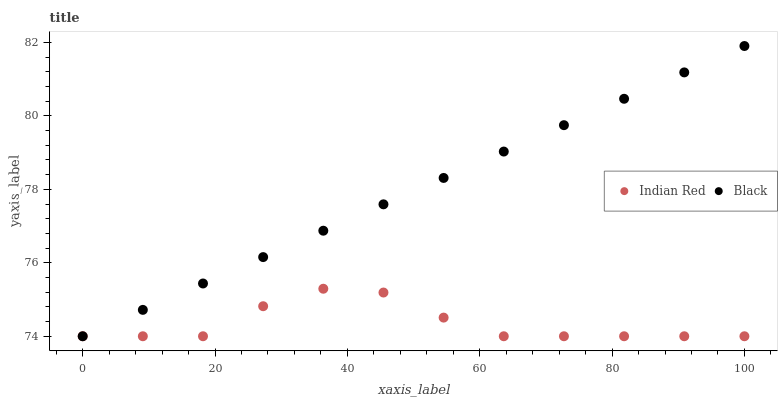Does Indian Red have the minimum area under the curve?
Answer yes or no. Yes. Does Black have the maximum area under the curve?
Answer yes or no. Yes. Does Indian Red have the maximum area under the curve?
Answer yes or no. No. Is Black the smoothest?
Answer yes or no. Yes. Is Indian Red the roughest?
Answer yes or no. Yes. Is Indian Red the smoothest?
Answer yes or no. No. Does Black have the lowest value?
Answer yes or no. Yes. Does Black have the highest value?
Answer yes or no. Yes. Does Indian Red have the highest value?
Answer yes or no. No. Does Black intersect Indian Red?
Answer yes or no. Yes. Is Black less than Indian Red?
Answer yes or no. No. Is Black greater than Indian Red?
Answer yes or no. No. 